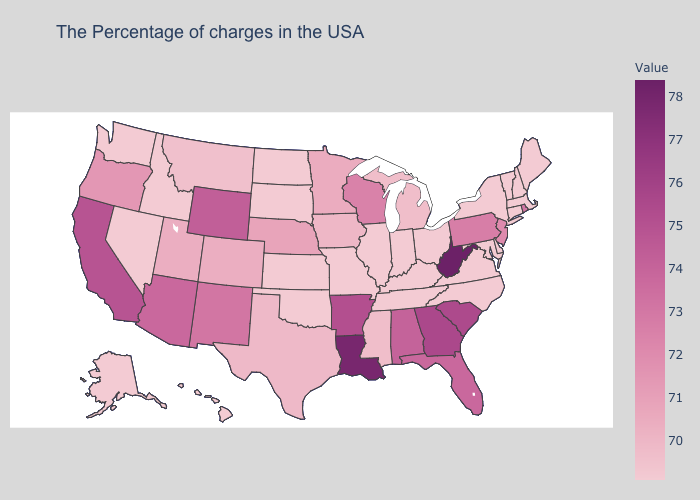Among the states that border Texas , which have the lowest value?
Write a very short answer. Oklahoma. Does the map have missing data?
Write a very short answer. No. Does Alaska have the lowest value in the West?
Concise answer only. Yes. Which states have the highest value in the USA?
Answer briefly. West Virginia. Does South Carolina have the lowest value in the South?
Write a very short answer. No. Does Oregon have the lowest value in the West?
Answer briefly. No. 